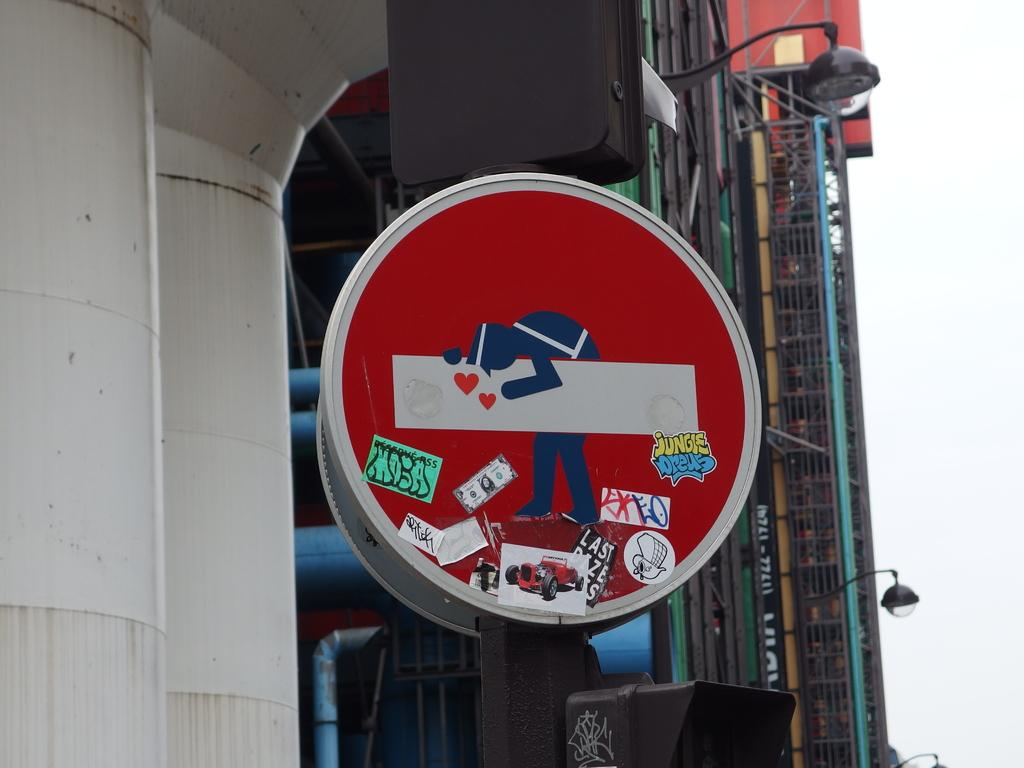Provide a one-sentence caption for the provided image. A round red sign has an image carrying something with various stickers covering the bottom of the sign. 